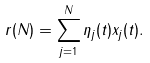Convert formula to latex. <formula><loc_0><loc_0><loc_500><loc_500>r ( N ) = \sum _ { j = 1 } ^ { N } { \eta } _ { j } ( t ) x _ { j } ( t ) .</formula> 